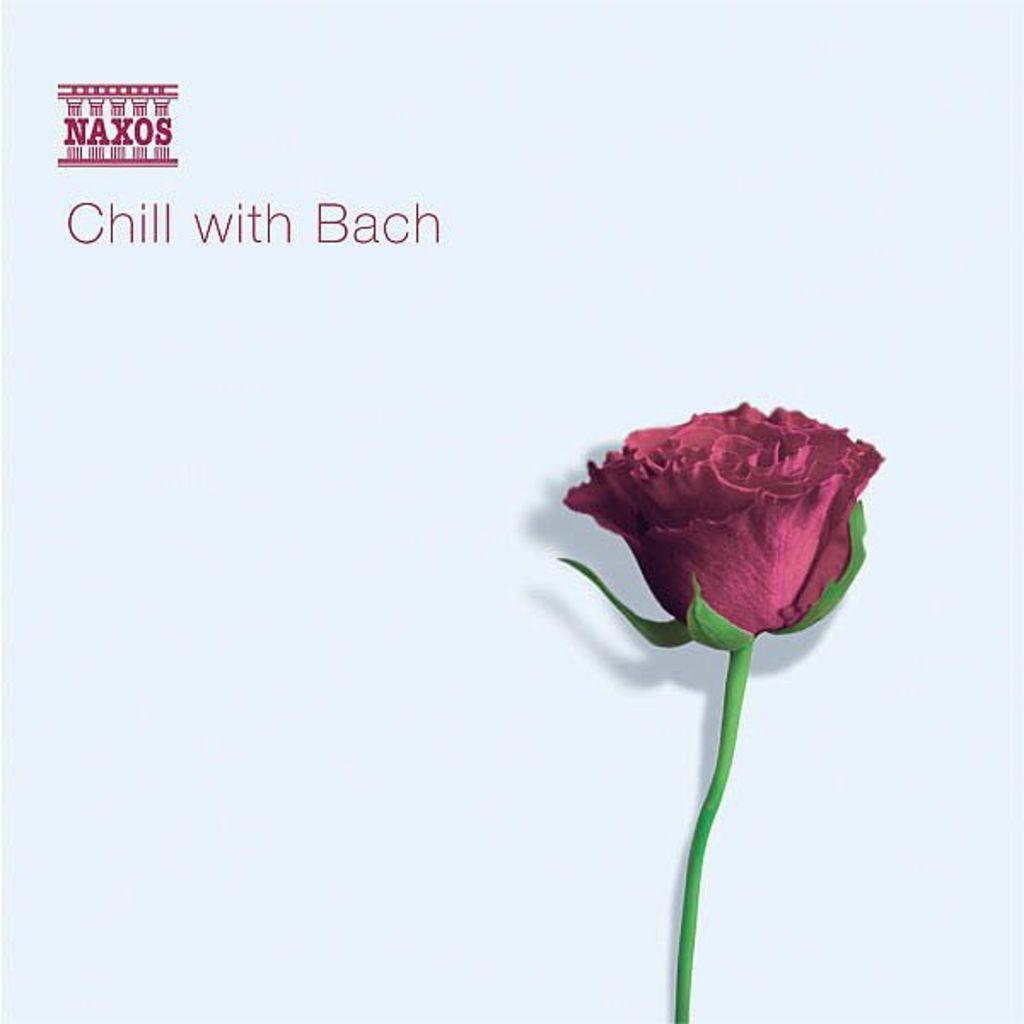What type of flower is in the image? There is a rose in the image. What colors can be seen on the rose? The rose has red and green colors. What else is present in the image besides the rose? There is text in the image. What does the text say? The text says "chill with Bach". On what surface is the text written? The text is written on a white surface. Can you see any bones in the image? There are no bones present in the image. Is there a window visible in the image? The provided facts do not mention a window, so we cannot determine if one is present in the image. --- Facts: 1. There is a cat in the image. 2. The cat is sitting on a chair. 3. The chair has a patterned fabric. 4. There is a plant in the background. 5. The plant has green leaves. Absurd Topics: bicycle, ocean, volcano Conversation: What type of animal is in the image? There is a cat in the image. What is the cat doing in the image? The cat is sitting on a chair. Can you describe the chair the cat is sitting on? The chair has a patterned fabric. What else can be seen in the background of the image? There is a plant in the background. What is the appearance of the plant? The plant has green leaves. Reasoning: Let's think step by step in order to produce the conversation. We start by identifying the main subject in the image, which is the cat. Then, we describe the cat's action and location. Next, we provide details about the chair the cat is sitting on. Finally, we mention the presence of a plant in the background and describe its appearance. Each question is designed to elicit a specific detail about the image that is known from the provided facts. Absurd Question/Answer: Can you see any bicycles in the image? There are no bicycles present in the image. Is there an ocean visible in the image? The provided facts do not mention an ocean, so we cannot determine if one is present in the image. 